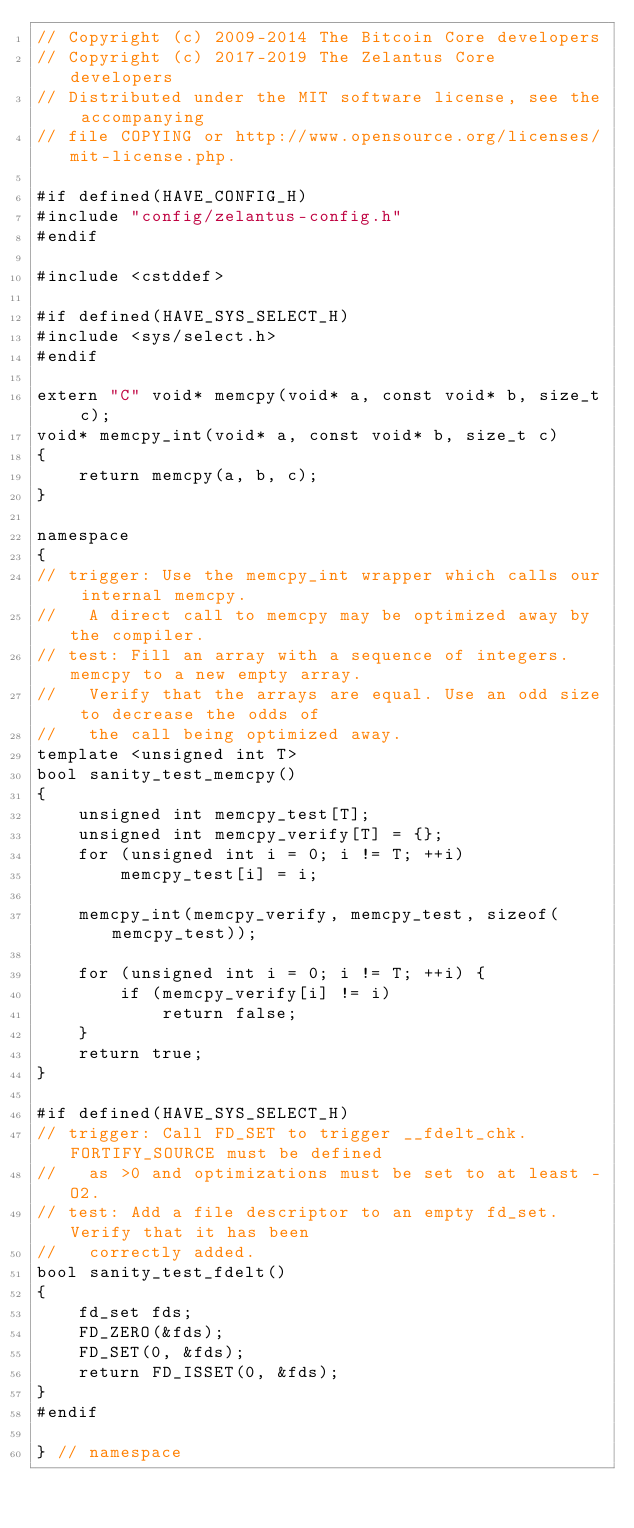Convert code to text. <code><loc_0><loc_0><loc_500><loc_500><_C++_>// Copyright (c) 2009-2014 The Bitcoin Core developers
// Copyright (c) 2017-2019 The Zelantus Core developers
// Distributed under the MIT software license, see the accompanying
// file COPYING or http://www.opensource.org/licenses/mit-license.php.

#if defined(HAVE_CONFIG_H)
#include "config/zelantus-config.h"
#endif

#include <cstddef>

#if defined(HAVE_SYS_SELECT_H)
#include <sys/select.h>
#endif

extern "C" void* memcpy(void* a, const void* b, size_t c);
void* memcpy_int(void* a, const void* b, size_t c)
{
    return memcpy(a, b, c);
}

namespace
{
// trigger: Use the memcpy_int wrapper which calls our internal memcpy.
//   A direct call to memcpy may be optimized away by the compiler.
// test: Fill an array with a sequence of integers. memcpy to a new empty array.
//   Verify that the arrays are equal. Use an odd size to decrease the odds of
//   the call being optimized away.
template <unsigned int T>
bool sanity_test_memcpy()
{
    unsigned int memcpy_test[T];
    unsigned int memcpy_verify[T] = {};
    for (unsigned int i = 0; i != T; ++i)
        memcpy_test[i] = i;

    memcpy_int(memcpy_verify, memcpy_test, sizeof(memcpy_test));

    for (unsigned int i = 0; i != T; ++i) {
        if (memcpy_verify[i] != i)
            return false;
    }
    return true;
}

#if defined(HAVE_SYS_SELECT_H)
// trigger: Call FD_SET to trigger __fdelt_chk. FORTIFY_SOURCE must be defined
//   as >0 and optimizations must be set to at least -O2.
// test: Add a file descriptor to an empty fd_set. Verify that it has been
//   correctly added.
bool sanity_test_fdelt()
{
    fd_set fds;
    FD_ZERO(&fds);
    FD_SET(0, &fds);
    return FD_ISSET(0, &fds);
}
#endif

} // namespace
</code> 